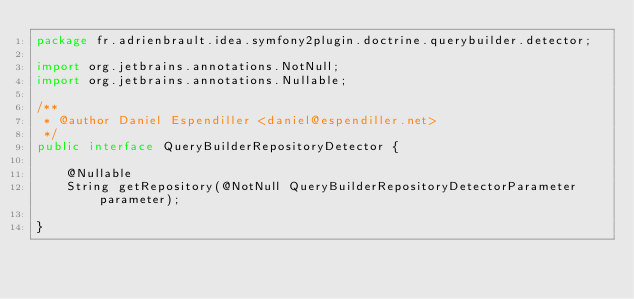<code> <loc_0><loc_0><loc_500><loc_500><_Java_>package fr.adrienbrault.idea.symfony2plugin.doctrine.querybuilder.detector;

import org.jetbrains.annotations.NotNull;
import org.jetbrains.annotations.Nullable;

/**
 * @author Daniel Espendiller <daniel@espendiller.net>
 */
public interface QueryBuilderRepositoryDetector {

    @Nullable
    String getRepository(@NotNull QueryBuilderRepositoryDetectorParameter parameter);

}
</code> 